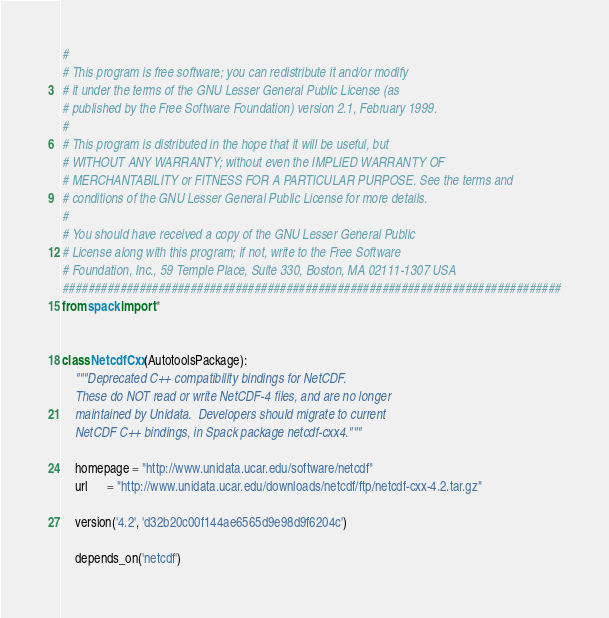Convert code to text. <code><loc_0><loc_0><loc_500><loc_500><_Python_>#
# This program is free software; you can redistribute it and/or modify
# it under the terms of the GNU Lesser General Public License (as
# published by the Free Software Foundation) version 2.1, February 1999.
#
# This program is distributed in the hope that it will be useful, but
# WITHOUT ANY WARRANTY; without even the IMPLIED WARRANTY OF
# MERCHANTABILITY or FITNESS FOR A PARTICULAR PURPOSE. See the terms and
# conditions of the GNU Lesser General Public License for more details.
#
# You should have received a copy of the GNU Lesser General Public
# License along with this program; if not, write to the Free Software
# Foundation, Inc., 59 Temple Place, Suite 330, Boston, MA 02111-1307 USA
##############################################################################
from spack import *


class NetcdfCxx(AutotoolsPackage):
    """Deprecated C++ compatibility bindings for NetCDF.
    These do NOT read or write NetCDF-4 files, and are no longer
    maintained by Unidata.  Developers should migrate to current
    NetCDF C++ bindings, in Spack package netcdf-cxx4."""

    homepage = "http://www.unidata.ucar.edu/software/netcdf"
    url      = "http://www.unidata.ucar.edu/downloads/netcdf/ftp/netcdf-cxx-4.2.tar.gz"

    version('4.2', 'd32b20c00f144ae6565d9e98d9f6204c')

    depends_on('netcdf')
</code> 